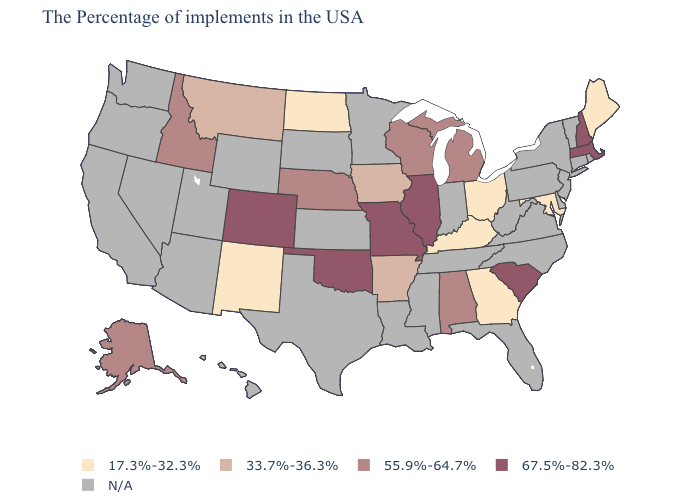Does the first symbol in the legend represent the smallest category?
Concise answer only. Yes. Among the states that border Virginia , which have the lowest value?
Be succinct. Maryland, Kentucky. Does Alaska have the highest value in the USA?
Short answer required. No. Name the states that have a value in the range 67.5%-82.3%?
Concise answer only. Massachusetts, New Hampshire, South Carolina, Illinois, Missouri, Oklahoma, Colorado. What is the value of South Carolina?
Be succinct. 67.5%-82.3%. Among the states that border Indiana , does Kentucky have the highest value?
Give a very brief answer. No. Does Illinois have the highest value in the MidWest?
Write a very short answer. Yes. What is the value of West Virginia?
Write a very short answer. N/A. Among the states that border Oregon , which have the highest value?
Answer briefly. Idaho. Does Missouri have the highest value in the MidWest?
Write a very short answer. Yes. Which states have the lowest value in the West?
Keep it brief. New Mexico. Which states have the lowest value in the USA?
Quick response, please. Maine, Maryland, Ohio, Georgia, Kentucky, North Dakota, New Mexico. Among the states that border Montana , which have the highest value?
Short answer required. Idaho. What is the value of South Carolina?
Keep it brief. 67.5%-82.3%. 